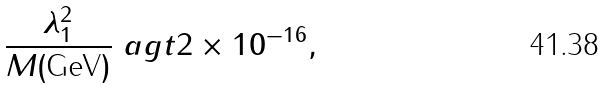<formula> <loc_0><loc_0><loc_500><loc_500>\frac { \lambda _ { 1 } ^ { 2 } } { M ( \text {GeV} ) } \ a g t 2 \times 1 0 ^ { - 1 6 } ,</formula> 